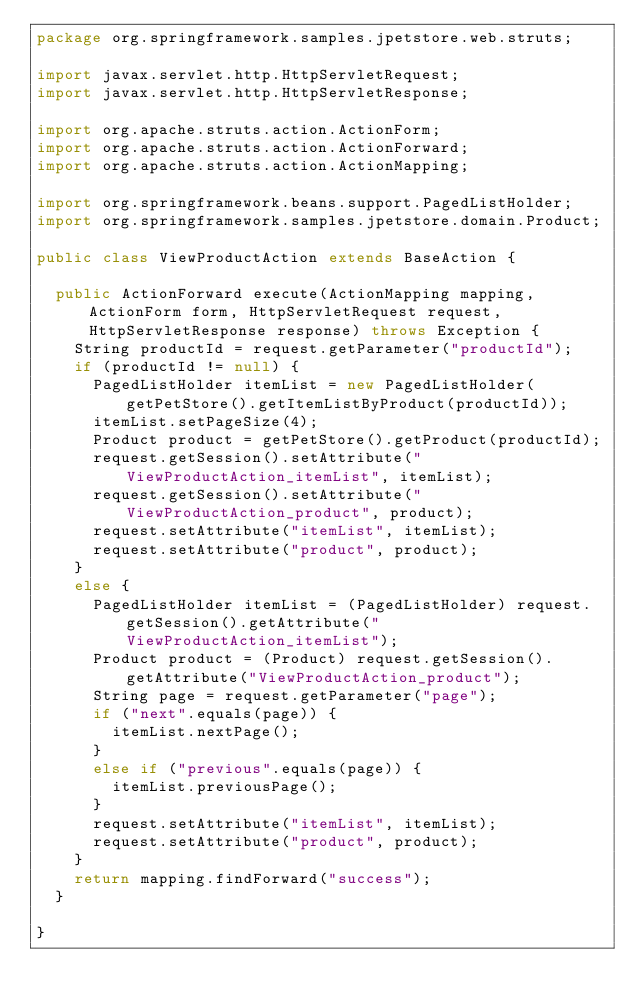Convert code to text. <code><loc_0><loc_0><loc_500><loc_500><_Java_>package org.springframework.samples.jpetstore.web.struts;

import javax.servlet.http.HttpServletRequest;
import javax.servlet.http.HttpServletResponse;

import org.apache.struts.action.ActionForm;
import org.apache.struts.action.ActionForward;
import org.apache.struts.action.ActionMapping;

import org.springframework.beans.support.PagedListHolder;
import org.springframework.samples.jpetstore.domain.Product;

public class ViewProductAction extends BaseAction {

  public ActionForward execute(ActionMapping mapping, ActionForm form, HttpServletRequest request, HttpServletResponse response) throws Exception {
    String productId = request.getParameter("productId");
    if (productId != null) {
			PagedListHolder itemList = new PagedListHolder(getPetStore().getItemListByProduct(productId));
			itemList.setPageSize(4);
			Product product = getPetStore().getProduct(productId);
      request.getSession().setAttribute("ViewProductAction_itemList", itemList);
			request.getSession().setAttribute("ViewProductAction_product", product);
			request.setAttribute("itemList", itemList);
      request.setAttribute("product", product);
    }
		else {
			PagedListHolder itemList = (PagedListHolder) request.getSession().getAttribute("ViewProductAction_itemList");
			Product product = (Product) request.getSession().getAttribute("ViewProductAction_product");
      String page = request.getParameter("page");
      if ("next".equals(page)) {
        itemList.nextPage();
      }
			else if ("previous".equals(page)) {
        itemList.previousPage();
      }
			request.setAttribute("itemList", itemList);
      request.setAttribute("product", product);
    }
    return mapping.findForward("success");
  }

}
</code> 